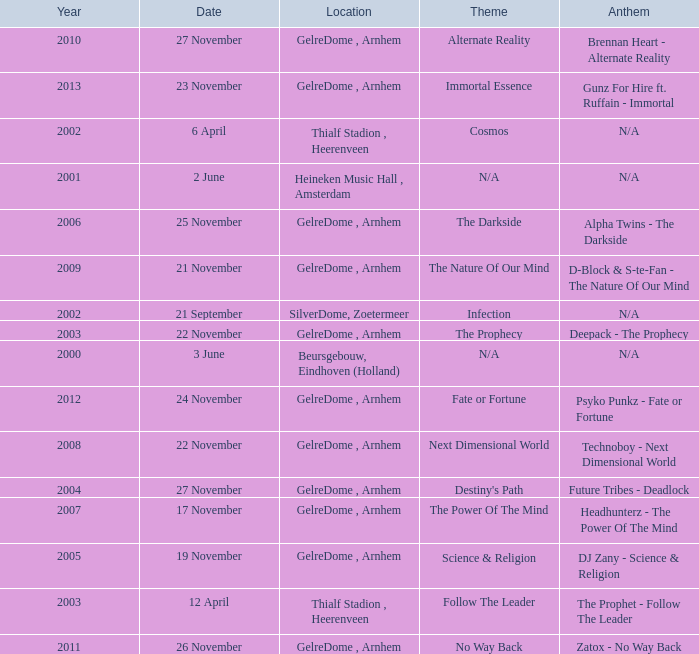What is the location in 2007? GelreDome , Arnhem. 